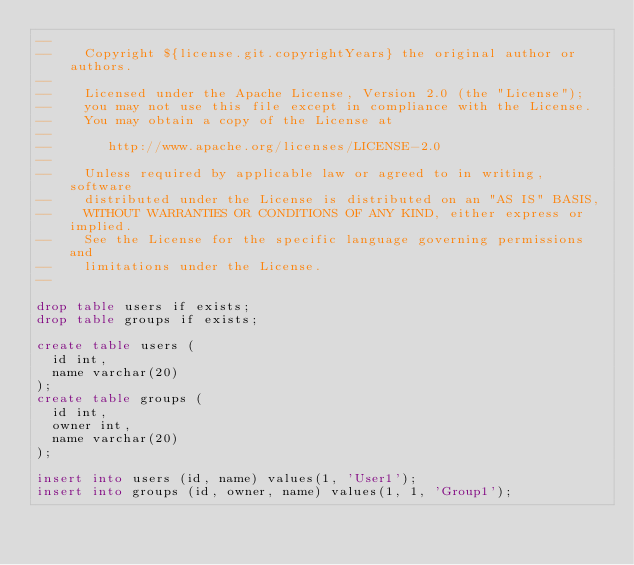Convert code to text. <code><loc_0><loc_0><loc_500><loc_500><_SQL_>--
--    Copyright ${license.git.copyrightYears} the original author or authors.
--
--    Licensed under the Apache License, Version 2.0 (the "License");
--    you may not use this file except in compliance with the License.
--    You may obtain a copy of the License at
--
--       http://www.apache.org/licenses/LICENSE-2.0
--
--    Unless required by applicable law or agreed to in writing, software
--    distributed under the License is distributed on an "AS IS" BASIS,
--    WITHOUT WARRANTIES OR CONDITIONS OF ANY KIND, either express or implied.
--    See the License for the specific language governing permissions and
--    limitations under the License.
--

drop table users if exists;
drop table groups if exists;

create table users (
  id int,
  name varchar(20)
);
create table groups (
  id int,
  owner int,
  name varchar(20)
);

insert into users (id, name) values(1, 'User1');
insert into groups (id, owner, name) values(1, 1, 'Group1');
</code> 